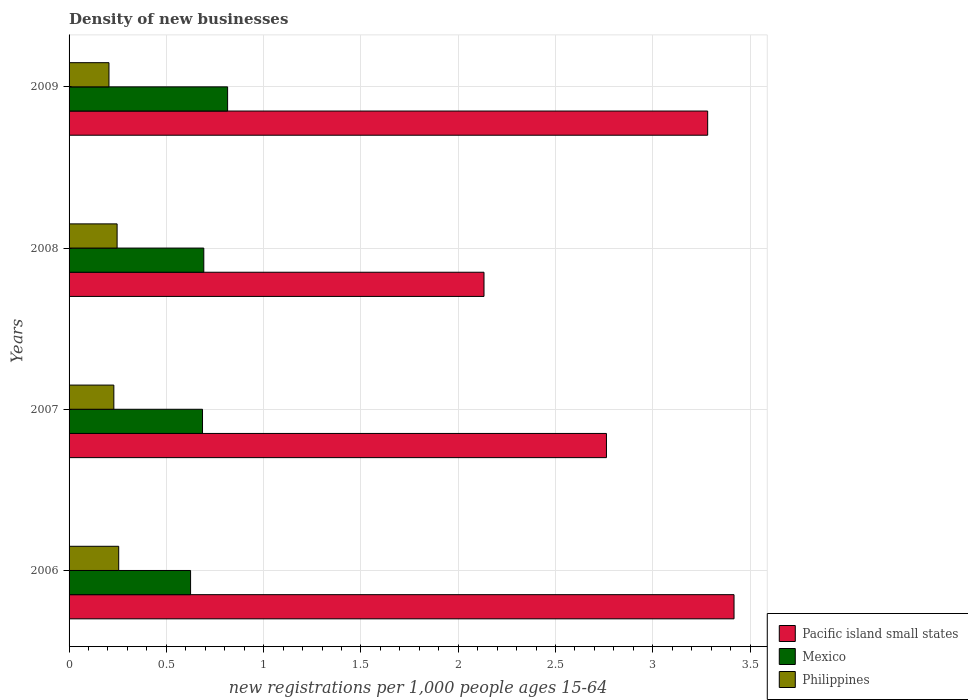How many different coloured bars are there?
Keep it short and to the point. 3. Are the number of bars per tick equal to the number of legend labels?
Offer a very short reply. Yes. What is the number of new registrations in Mexico in 2009?
Offer a very short reply. 0.81. Across all years, what is the maximum number of new registrations in Pacific island small states?
Your response must be concise. 3.42. Across all years, what is the minimum number of new registrations in Pacific island small states?
Your response must be concise. 2.13. In which year was the number of new registrations in Philippines minimum?
Provide a succinct answer. 2009. What is the total number of new registrations in Mexico in the graph?
Make the answer very short. 2.82. What is the difference between the number of new registrations in Pacific island small states in 2007 and that in 2008?
Make the answer very short. 0.63. What is the difference between the number of new registrations in Mexico in 2009 and the number of new registrations in Pacific island small states in 2007?
Make the answer very short. -1.95. What is the average number of new registrations in Pacific island small states per year?
Give a very brief answer. 2.9. In the year 2007, what is the difference between the number of new registrations in Philippines and number of new registrations in Pacific island small states?
Offer a very short reply. -2.53. In how many years, is the number of new registrations in Mexico greater than 3.3 ?
Your answer should be compact. 0. What is the ratio of the number of new registrations in Pacific island small states in 2006 to that in 2007?
Ensure brevity in your answer.  1.24. Is the number of new registrations in Mexico in 2008 less than that in 2009?
Keep it short and to the point. Yes. What is the difference between the highest and the second highest number of new registrations in Mexico?
Provide a succinct answer. 0.12. What is the difference between the highest and the lowest number of new registrations in Pacific island small states?
Keep it short and to the point. 1.29. What does the 3rd bar from the top in 2009 represents?
Make the answer very short. Pacific island small states. What does the 1st bar from the bottom in 2009 represents?
Offer a very short reply. Pacific island small states. Are all the bars in the graph horizontal?
Your response must be concise. Yes. How many years are there in the graph?
Give a very brief answer. 4. Are the values on the major ticks of X-axis written in scientific E-notation?
Keep it short and to the point. No. Does the graph contain any zero values?
Your answer should be compact. No. Does the graph contain grids?
Offer a terse response. Yes. How are the legend labels stacked?
Your answer should be compact. Vertical. What is the title of the graph?
Offer a very short reply. Density of new businesses. Does "Qatar" appear as one of the legend labels in the graph?
Give a very brief answer. No. What is the label or title of the X-axis?
Your answer should be compact. New registrations per 1,0 people ages 15-64. What is the new registrations per 1,000 people ages 15-64 in Pacific island small states in 2006?
Keep it short and to the point. 3.42. What is the new registrations per 1,000 people ages 15-64 in Mexico in 2006?
Your answer should be compact. 0.62. What is the new registrations per 1,000 people ages 15-64 of Philippines in 2006?
Keep it short and to the point. 0.26. What is the new registrations per 1,000 people ages 15-64 of Pacific island small states in 2007?
Give a very brief answer. 2.76. What is the new registrations per 1,000 people ages 15-64 in Mexico in 2007?
Offer a very short reply. 0.69. What is the new registrations per 1,000 people ages 15-64 in Philippines in 2007?
Offer a terse response. 0.23. What is the new registrations per 1,000 people ages 15-64 in Pacific island small states in 2008?
Your answer should be very brief. 2.13. What is the new registrations per 1,000 people ages 15-64 in Mexico in 2008?
Give a very brief answer. 0.69. What is the new registrations per 1,000 people ages 15-64 in Philippines in 2008?
Your answer should be very brief. 0.25. What is the new registrations per 1,000 people ages 15-64 of Pacific island small states in 2009?
Provide a short and direct response. 3.28. What is the new registrations per 1,000 people ages 15-64 of Mexico in 2009?
Provide a succinct answer. 0.81. What is the new registrations per 1,000 people ages 15-64 of Philippines in 2009?
Your answer should be very brief. 0.21. Across all years, what is the maximum new registrations per 1,000 people ages 15-64 in Pacific island small states?
Provide a short and direct response. 3.42. Across all years, what is the maximum new registrations per 1,000 people ages 15-64 in Mexico?
Make the answer very short. 0.81. Across all years, what is the maximum new registrations per 1,000 people ages 15-64 in Philippines?
Give a very brief answer. 0.26. Across all years, what is the minimum new registrations per 1,000 people ages 15-64 of Pacific island small states?
Give a very brief answer. 2.13. Across all years, what is the minimum new registrations per 1,000 people ages 15-64 of Mexico?
Ensure brevity in your answer.  0.62. Across all years, what is the minimum new registrations per 1,000 people ages 15-64 of Philippines?
Provide a short and direct response. 0.21. What is the total new registrations per 1,000 people ages 15-64 in Pacific island small states in the graph?
Your response must be concise. 11.59. What is the total new registrations per 1,000 people ages 15-64 in Mexico in the graph?
Ensure brevity in your answer.  2.82. What is the total new registrations per 1,000 people ages 15-64 in Philippines in the graph?
Keep it short and to the point. 0.94. What is the difference between the new registrations per 1,000 people ages 15-64 in Pacific island small states in 2006 and that in 2007?
Keep it short and to the point. 0.66. What is the difference between the new registrations per 1,000 people ages 15-64 of Mexico in 2006 and that in 2007?
Offer a terse response. -0.06. What is the difference between the new registrations per 1,000 people ages 15-64 in Philippines in 2006 and that in 2007?
Give a very brief answer. 0.03. What is the difference between the new registrations per 1,000 people ages 15-64 of Pacific island small states in 2006 and that in 2008?
Your answer should be very brief. 1.28. What is the difference between the new registrations per 1,000 people ages 15-64 of Mexico in 2006 and that in 2008?
Ensure brevity in your answer.  -0.07. What is the difference between the new registrations per 1,000 people ages 15-64 in Philippines in 2006 and that in 2008?
Offer a terse response. 0.01. What is the difference between the new registrations per 1,000 people ages 15-64 of Pacific island small states in 2006 and that in 2009?
Give a very brief answer. 0.14. What is the difference between the new registrations per 1,000 people ages 15-64 in Mexico in 2006 and that in 2009?
Your answer should be very brief. -0.19. What is the difference between the new registrations per 1,000 people ages 15-64 of Philippines in 2006 and that in 2009?
Your answer should be compact. 0.05. What is the difference between the new registrations per 1,000 people ages 15-64 in Pacific island small states in 2007 and that in 2008?
Keep it short and to the point. 0.63. What is the difference between the new registrations per 1,000 people ages 15-64 of Mexico in 2007 and that in 2008?
Provide a succinct answer. -0.01. What is the difference between the new registrations per 1,000 people ages 15-64 of Philippines in 2007 and that in 2008?
Keep it short and to the point. -0.02. What is the difference between the new registrations per 1,000 people ages 15-64 of Pacific island small states in 2007 and that in 2009?
Your answer should be compact. -0.52. What is the difference between the new registrations per 1,000 people ages 15-64 in Mexico in 2007 and that in 2009?
Your answer should be compact. -0.13. What is the difference between the new registrations per 1,000 people ages 15-64 of Philippines in 2007 and that in 2009?
Your answer should be very brief. 0.03. What is the difference between the new registrations per 1,000 people ages 15-64 of Pacific island small states in 2008 and that in 2009?
Your response must be concise. -1.15. What is the difference between the new registrations per 1,000 people ages 15-64 in Mexico in 2008 and that in 2009?
Your answer should be compact. -0.12. What is the difference between the new registrations per 1,000 people ages 15-64 of Philippines in 2008 and that in 2009?
Offer a terse response. 0.04. What is the difference between the new registrations per 1,000 people ages 15-64 in Pacific island small states in 2006 and the new registrations per 1,000 people ages 15-64 in Mexico in 2007?
Provide a short and direct response. 2.73. What is the difference between the new registrations per 1,000 people ages 15-64 in Pacific island small states in 2006 and the new registrations per 1,000 people ages 15-64 in Philippines in 2007?
Your response must be concise. 3.19. What is the difference between the new registrations per 1,000 people ages 15-64 in Mexico in 2006 and the new registrations per 1,000 people ages 15-64 in Philippines in 2007?
Your response must be concise. 0.39. What is the difference between the new registrations per 1,000 people ages 15-64 in Pacific island small states in 2006 and the new registrations per 1,000 people ages 15-64 in Mexico in 2008?
Give a very brief answer. 2.73. What is the difference between the new registrations per 1,000 people ages 15-64 in Pacific island small states in 2006 and the new registrations per 1,000 people ages 15-64 in Philippines in 2008?
Keep it short and to the point. 3.17. What is the difference between the new registrations per 1,000 people ages 15-64 in Mexico in 2006 and the new registrations per 1,000 people ages 15-64 in Philippines in 2008?
Ensure brevity in your answer.  0.38. What is the difference between the new registrations per 1,000 people ages 15-64 in Pacific island small states in 2006 and the new registrations per 1,000 people ages 15-64 in Mexico in 2009?
Keep it short and to the point. 2.6. What is the difference between the new registrations per 1,000 people ages 15-64 in Pacific island small states in 2006 and the new registrations per 1,000 people ages 15-64 in Philippines in 2009?
Give a very brief answer. 3.21. What is the difference between the new registrations per 1,000 people ages 15-64 in Mexico in 2006 and the new registrations per 1,000 people ages 15-64 in Philippines in 2009?
Your answer should be compact. 0.42. What is the difference between the new registrations per 1,000 people ages 15-64 of Pacific island small states in 2007 and the new registrations per 1,000 people ages 15-64 of Mexico in 2008?
Provide a short and direct response. 2.07. What is the difference between the new registrations per 1,000 people ages 15-64 in Pacific island small states in 2007 and the new registrations per 1,000 people ages 15-64 in Philippines in 2008?
Your response must be concise. 2.52. What is the difference between the new registrations per 1,000 people ages 15-64 in Mexico in 2007 and the new registrations per 1,000 people ages 15-64 in Philippines in 2008?
Your response must be concise. 0.44. What is the difference between the new registrations per 1,000 people ages 15-64 of Pacific island small states in 2007 and the new registrations per 1,000 people ages 15-64 of Mexico in 2009?
Your answer should be compact. 1.95. What is the difference between the new registrations per 1,000 people ages 15-64 in Pacific island small states in 2007 and the new registrations per 1,000 people ages 15-64 in Philippines in 2009?
Give a very brief answer. 2.56. What is the difference between the new registrations per 1,000 people ages 15-64 of Mexico in 2007 and the new registrations per 1,000 people ages 15-64 of Philippines in 2009?
Keep it short and to the point. 0.48. What is the difference between the new registrations per 1,000 people ages 15-64 in Pacific island small states in 2008 and the new registrations per 1,000 people ages 15-64 in Mexico in 2009?
Provide a short and direct response. 1.32. What is the difference between the new registrations per 1,000 people ages 15-64 in Pacific island small states in 2008 and the new registrations per 1,000 people ages 15-64 in Philippines in 2009?
Keep it short and to the point. 1.93. What is the difference between the new registrations per 1,000 people ages 15-64 in Mexico in 2008 and the new registrations per 1,000 people ages 15-64 in Philippines in 2009?
Your answer should be compact. 0.49. What is the average new registrations per 1,000 people ages 15-64 in Pacific island small states per year?
Your response must be concise. 2.9. What is the average new registrations per 1,000 people ages 15-64 of Mexico per year?
Your answer should be compact. 0.7. What is the average new registrations per 1,000 people ages 15-64 of Philippines per year?
Offer a very short reply. 0.23. In the year 2006, what is the difference between the new registrations per 1,000 people ages 15-64 in Pacific island small states and new registrations per 1,000 people ages 15-64 in Mexico?
Your response must be concise. 2.79. In the year 2006, what is the difference between the new registrations per 1,000 people ages 15-64 of Pacific island small states and new registrations per 1,000 people ages 15-64 of Philippines?
Your response must be concise. 3.16. In the year 2006, what is the difference between the new registrations per 1,000 people ages 15-64 of Mexico and new registrations per 1,000 people ages 15-64 of Philippines?
Make the answer very short. 0.37. In the year 2007, what is the difference between the new registrations per 1,000 people ages 15-64 in Pacific island small states and new registrations per 1,000 people ages 15-64 in Mexico?
Your answer should be very brief. 2.08. In the year 2007, what is the difference between the new registrations per 1,000 people ages 15-64 in Pacific island small states and new registrations per 1,000 people ages 15-64 in Philippines?
Provide a short and direct response. 2.53. In the year 2007, what is the difference between the new registrations per 1,000 people ages 15-64 in Mexico and new registrations per 1,000 people ages 15-64 in Philippines?
Offer a terse response. 0.46. In the year 2008, what is the difference between the new registrations per 1,000 people ages 15-64 of Pacific island small states and new registrations per 1,000 people ages 15-64 of Mexico?
Provide a short and direct response. 1.44. In the year 2008, what is the difference between the new registrations per 1,000 people ages 15-64 of Pacific island small states and new registrations per 1,000 people ages 15-64 of Philippines?
Your answer should be very brief. 1.89. In the year 2008, what is the difference between the new registrations per 1,000 people ages 15-64 of Mexico and new registrations per 1,000 people ages 15-64 of Philippines?
Give a very brief answer. 0.45. In the year 2009, what is the difference between the new registrations per 1,000 people ages 15-64 of Pacific island small states and new registrations per 1,000 people ages 15-64 of Mexico?
Keep it short and to the point. 2.47. In the year 2009, what is the difference between the new registrations per 1,000 people ages 15-64 in Pacific island small states and new registrations per 1,000 people ages 15-64 in Philippines?
Offer a very short reply. 3.08. In the year 2009, what is the difference between the new registrations per 1,000 people ages 15-64 in Mexico and new registrations per 1,000 people ages 15-64 in Philippines?
Give a very brief answer. 0.61. What is the ratio of the new registrations per 1,000 people ages 15-64 in Pacific island small states in 2006 to that in 2007?
Give a very brief answer. 1.24. What is the ratio of the new registrations per 1,000 people ages 15-64 in Mexico in 2006 to that in 2007?
Your answer should be compact. 0.91. What is the ratio of the new registrations per 1,000 people ages 15-64 of Philippines in 2006 to that in 2007?
Provide a short and direct response. 1.11. What is the ratio of the new registrations per 1,000 people ages 15-64 of Pacific island small states in 2006 to that in 2008?
Keep it short and to the point. 1.6. What is the ratio of the new registrations per 1,000 people ages 15-64 of Mexico in 2006 to that in 2008?
Provide a short and direct response. 0.9. What is the ratio of the new registrations per 1,000 people ages 15-64 of Philippines in 2006 to that in 2008?
Your answer should be very brief. 1.03. What is the ratio of the new registrations per 1,000 people ages 15-64 of Pacific island small states in 2006 to that in 2009?
Provide a short and direct response. 1.04. What is the ratio of the new registrations per 1,000 people ages 15-64 of Mexico in 2006 to that in 2009?
Offer a very short reply. 0.77. What is the ratio of the new registrations per 1,000 people ages 15-64 of Philippines in 2006 to that in 2009?
Ensure brevity in your answer.  1.24. What is the ratio of the new registrations per 1,000 people ages 15-64 in Pacific island small states in 2007 to that in 2008?
Ensure brevity in your answer.  1.3. What is the ratio of the new registrations per 1,000 people ages 15-64 of Mexico in 2007 to that in 2008?
Keep it short and to the point. 0.99. What is the ratio of the new registrations per 1,000 people ages 15-64 in Philippines in 2007 to that in 2008?
Ensure brevity in your answer.  0.93. What is the ratio of the new registrations per 1,000 people ages 15-64 of Pacific island small states in 2007 to that in 2009?
Your answer should be very brief. 0.84. What is the ratio of the new registrations per 1,000 people ages 15-64 in Mexico in 2007 to that in 2009?
Provide a short and direct response. 0.84. What is the ratio of the new registrations per 1,000 people ages 15-64 of Philippines in 2007 to that in 2009?
Offer a terse response. 1.12. What is the ratio of the new registrations per 1,000 people ages 15-64 of Pacific island small states in 2008 to that in 2009?
Provide a short and direct response. 0.65. What is the ratio of the new registrations per 1,000 people ages 15-64 of Mexico in 2008 to that in 2009?
Ensure brevity in your answer.  0.85. What is the ratio of the new registrations per 1,000 people ages 15-64 in Philippines in 2008 to that in 2009?
Give a very brief answer. 1.2. What is the difference between the highest and the second highest new registrations per 1,000 people ages 15-64 of Pacific island small states?
Your response must be concise. 0.14. What is the difference between the highest and the second highest new registrations per 1,000 people ages 15-64 in Mexico?
Offer a terse response. 0.12. What is the difference between the highest and the second highest new registrations per 1,000 people ages 15-64 of Philippines?
Offer a terse response. 0.01. What is the difference between the highest and the lowest new registrations per 1,000 people ages 15-64 of Pacific island small states?
Your answer should be compact. 1.28. What is the difference between the highest and the lowest new registrations per 1,000 people ages 15-64 in Mexico?
Give a very brief answer. 0.19. What is the difference between the highest and the lowest new registrations per 1,000 people ages 15-64 of Philippines?
Your answer should be compact. 0.05. 